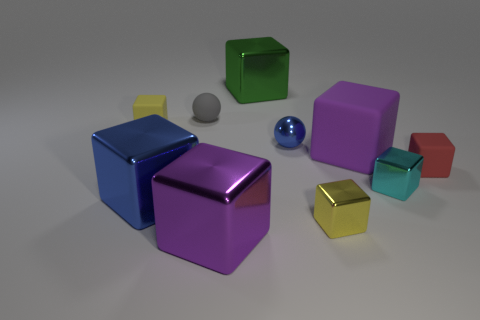Subtract all cyan cubes. How many cubes are left? 7 Subtract all small yellow metallic blocks. How many blocks are left? 7 Subtract 3 blocks. How many blocks are left? 5 Subtract all green cubes. Subtract all gray balls. How many cubes are left? 7 Subtract all balls. How many objects are left? 8 Add 6 small cyan cubes. How many small cyan cubes are left? 7 Add 4 large green metal objects. How many large green metal objects exist? 5 Subtract 0 red balls. How many objects are left? 10 Subtract all small brown matte balls. Subtract all yellow things. How many objects are left? 8 